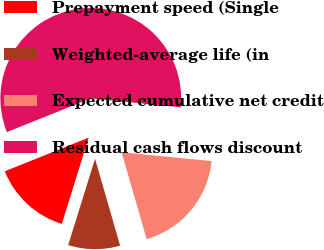Convert chart to OTSL. <chart><loc_0><loc_0><loc_500><loc_500><pie_chart><fcel>Prepayment speed (Single<fcel>Weighted-average life (in<fcel>Expected cumulative net credit<fcel>Residual cash flows discount<nl><fcel>14.12%<fcel>9.27%<fcel>18.97%<fcel>57.64%<nl></chart> 